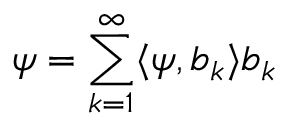<formula> <loc_0><loc_0><loc_500><loc_500>\psi = \sum _ { k = 1 } ^ { \infty } \langle \psi , b _ { k } \rangle b _ { k }</formula> 